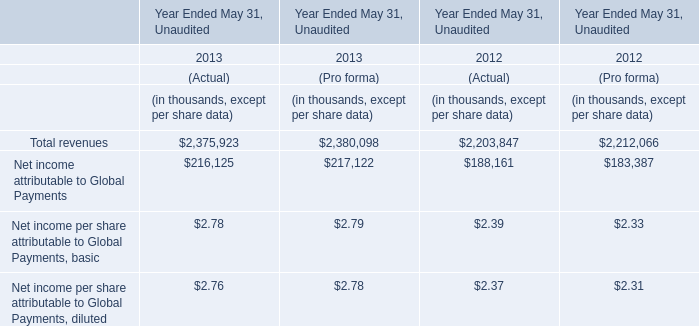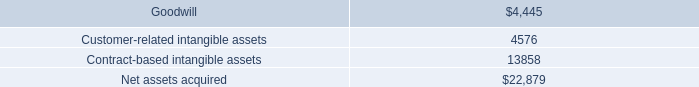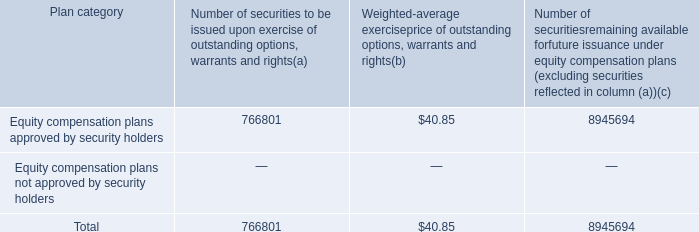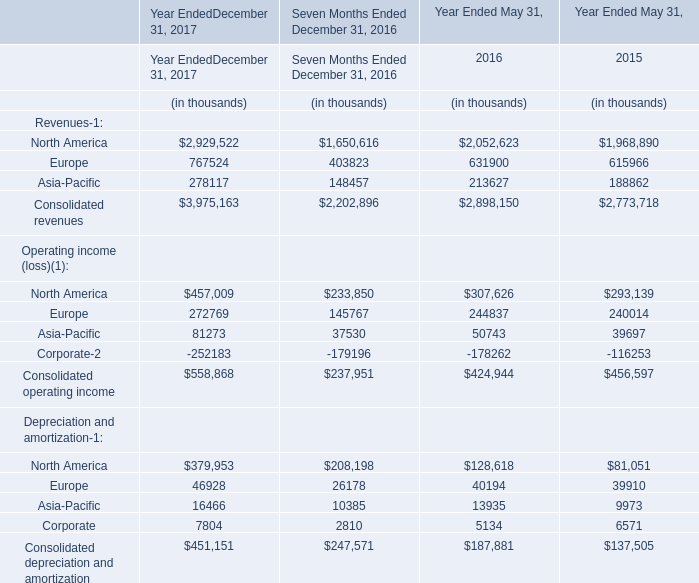What is the sum of Consolidated revenues in 2017 and Total revenues of (Pro forma) in 2013? (in thousand) 
Computations: (3975163 + 2380098)
Answer: 6355261.0. 